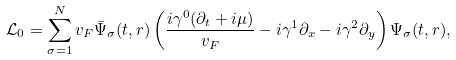Convert formula to latex. <formula><loc_0><loc_0><loc_500><loc_500>\mathcal { L } _ { 0 } = \sum _ { \sigma = 1 } ^ { N } v _ { F } \bar { \Psi } _ { \sigma } ( t , r ) \left ( \frac { i \gamma ^ { 0 } ( \partial _ { t } + i \mu ) } { v _ { F } } - i \gamma ^ { 1 } \partial _ { x } - i \gamma ^ { 2 } \partial _ { y } \right ) \Psi _ { \sigma } ( t , r ) ,</formula> 